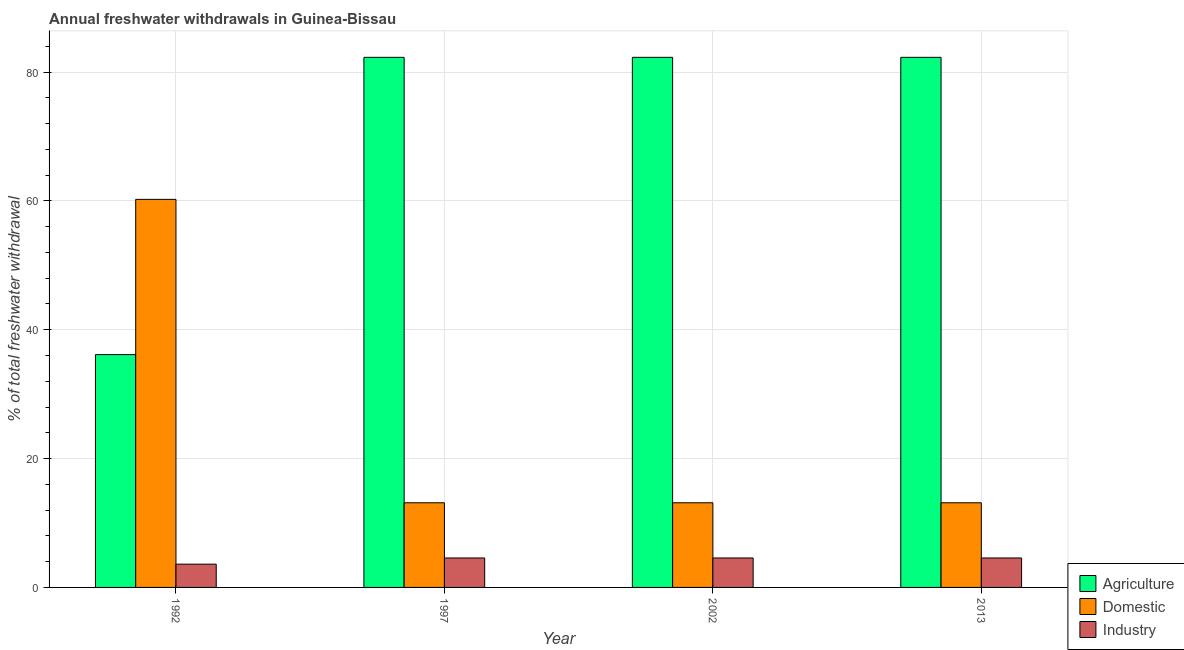How many groups of bars are there?
Your answer should be very brief. 4. How many bars are there on the 4th tick from the right?
Your answer should be compact. 3. What is the label of the 4th group of bars from the left?
Ensure brevity in your answer.  2013. What is the percentage of freshwater withdrawal for industry in 2002?
Make the answer very short. 4.57. Across all years, what is the maximum percentage of freshwater withdrawal for domestic purposes?
Make the answer very short. 60.24. Across all years, what is the minimum percentage of freshwater withdrawal for industry?
Provide a succinct answer. 3.61. What is the total percentage of freshwater withdrawal for agriculture in the graph?
Give a very brief answer. 283.01. What is the difference between the percentage of freshwater withdrawal for domestic purposes in 2002 and that in 2013?
Your answer should be very brief. 0. What is the difference between the percentage of freshwater withdrawal for agriculture in 1992 and the percentage of freshwater withdrawal for domestic purposes in 2002?
Provide a succinct answer. -46.15. What is the average percentage of freshwater withdrawal for domestic purposes per year?
Ensure brevity in your answer.  24.91. In the year 1997, what is the difference between the percentage of freshwater withdrawal for agriculture and percentage of freshwater withdrawal for domestic purposes?
Ensure brevity in your answer.  0. What is the difference between the highest and the second highest percentage of freshwater withdrawal for agriculture?
Your response must be concise. 0. What is the difference between the highest and the lowest percentage of freshwater withdrawal for industry?
Give a very brief answer. 0.96. In how many years, is the percentage of freshwater withdrawal for domestic purposes greater than the average percentage of freshwater withdrawal for domestic purposes taken over all years?
Offer a terse response. 1. Is the sum of the percentage of freshwater withdrawal for agriculture in 2002 and 2013 greater than the maximum percentage of freshwater withdrawal for domestic purposes across all years?
Your answer should be very brief. Yes. What does the 3rd bar from the left in 2013 represents?
Provide a short and direct response. Industry. What does the 1st bar from the right in 2002 represents?
Provide a short and direct response. Industry. Is it the case that in every year, the sum of the percentage of freshwater withdrawal for agriculture and percentage of freshwater withdrawal for domestic purposes is greater than the percentage of freshwater withdrawal for industry?
Provide a succinct answer. Yes. How many bars are there?
Offer a terse response. 12. What is the difference between two consecutive major ticks on the Y-axis?
Your answer should be very brief. 20. Are the values on the major ticks of Y-axis written in scientific E-notation?
Provide a succinct answer. No. Does the graph contain grids?
Your response must be concise. Yes. Where does the legend appear in the graph?
Your answer should be compact. Bottom right. How are the legend labels stacked?
Give a very brief answer. Vertical. What is the title of the graph?
Give a very brief answer. Annual freshwater withdrawals in Guinea-Bissau. Does "Renewable sources" appear as one of the legend labels in the graph?
Your answer should be very brief. No. What is the label or title of the X-axis?
Make the answer very short. Year. What is the label or title of the Y-axis?
Your answer should be compact. % of total freshwater withdrawal. What is the % of total freshwater withdrawal of Agriculture in 1992?
Your answer should be compact. 36.14. What is the % of total freshwater withdrawal of Domestic in 1992?
Your response must be concise. 60.24. What is the % of total freshwater withdrawal of Industry in 1992?
Keep it short and to the point. 3.61. What is the % of total freshwater withdrawal in Agriculture in 1997?
Ensure brevity in your answer.  82.29. What is the % of total freshwater withdrawal in Domestic in 1997?
Give a very brief answer. 13.14. What is the % of total freshwater withdrawal in Industry in 1997?
Give a very brief answer. 4.57. What is the % of total freshwater withdrawal of Agriculture in 2002?
Your answer should be compact. 82.29. What is the % of total freshwater withdrawal in Domestic in 2002?
Keep it short and to the point. 13.14. What is the % of total freshwater withdrawal of Industry in 2002?
Keep it short and to the point. 4.57. What is the % of total freshwater withdrawal of Agriculture in 2013?
Provide a short and direct response. 82.29. What is the % of total freshwater withdrawal in Domestic in 2013?
Provide a short and direct response. 13.14. What is the % of total freshwater withdrawal in Industry in 2013?
Your answer should be very brief. 4.57. Across all years, what is the maximum % of total freshwater withdrawal of Agriculture?
Give a very brief answer. 82.29. Across all years, what is the maximum % of total freshwater withdrawal in Domestic?
Your response must be concise. 60.24. Across all years, what is the maximum % of total freshwater withdrawal of Industry?
Give a very brief answer. 4.57. Across all years, what is the minimum % of total freshwater withdrawal of Agriculture?
Offer a terse response. 36.14. Across all years, what is the minimum % of total freshwater withdrawal of Domestic?
Give a very brief answer. 13.14. Across all years, what is the minimum % of total freshwater withdrawal in Industry?
Your answer should be very brief. 3.61. What is the total % of total freshwater withdrawal of Agriculture in the graph?
Keep it short and to the point. 283.01. What is the total % of total freshwater withdrawal in Domestic in the graph?
Offer a very short reply. 99.66. What is the total % of total freshwater withdrawal in Industry in the graph?
Keep it short and to the point. 17.33. What is the difference between the % of total freshwater withdrawal of Agriculture in 1992 and that in 1997?
Provide a short and direct response. -46.15. What is the difference between the % of total freshwater withdrawal of Domestic in 1992 and that in 1997?
Your answer should be compact. 47.1. What is the difference between the % of total freshwater withdrawal of Industry in 1992 and that in 1997?
Provide a short and direct response. -0.96. What is the difference between the % of total freshwater withdrawal of Agriculture in 1992 and that in 2002?
Your answer should be compact. -46.15. What is the difference between the % of total freshwater withdrawal of Domestic in 1992 and that in 2002?
Make the answer very short. 47.1. What is the difference between the % of total freshwater withdrawal in Industry in 1992 and that in 2002?
Provide a succinct answer. -0.96. What is the difference between the % of total freshwater withdrawal of Agriculture in 1992 and that in 2013?
Provide a succinct answer. -46.15. What is the difference between the % of total freshwater withdrawal in Domestic in 1992 and that in 2013?
Offer a terse response. 47.1. What is the difference between the % of total freshwater withdrawal in Industry in 1992 and that in 2013?
Your response must be concise. -0.96. What is the difference between the % of total freshwater withdrawal in Agriculture in 1997 and that in 2002?
Your answer should be compact. 0. What is the difference between the % of total freshwater withdrawal in Domestic in 1997 and that in 2013?
Provide a succinct answer. 0. What is the difference between the % of total freshwater withdrawal of Industry in 1997 and that in 2013?
Keep it short and to the point. 0. What is the difference between the % of total freshwater withdrawal in Agriculture in 2002 and that in 2013?
Make the answer very short. 0. What is the difference between the % of total freshwater withdrawal in Agriculture in 1992 and the % of total freshwater withdrawal in Domestic in 1997?
Ensure brevity in your answer.  23. What is the difference between the % of total freshwater withdrawal in Agriculture in 1992 and the % of total freshwater withdrawal in Industry in 1997?
Offer a terse response. 31.57. What is the difference between the % of total freshwater withdrawal of Domestic in 1992 and the % of total freshwater withdrawal of Industry in 1997?
Make the answer very short. 55.67. What is the difference between the % of total freshwater withdrawal in Agriculture in 1992 and the % of total freshwater withdrawal in Domestic in 2002?
Your answer should be very brief. 23. What is the difference between the % of total freshwater withdrawal of Agriculture in 1992 and the % of total freshwater withdrawal of Industry in 2002?
Offer a very short reply. 31.57. What is the difference between the % of total freshwater withdrawal in Domestic in 1992 and the % of total freshwater withdrawal in Industry in 2002?
Ensure brevity in your answer.  55.67. What is the difference between the % of total freshwater withdrawal of Agriculture in 1992 and the % of total freshwater withdrawal of Industry in 2013?
Provide a short and direct response. 31.57. What is the difference between the % of total freshwater withdrawal of Domestic in 1992 and the % of total freshwater withdrawal of Industry in 2013?
Offer a very short reply. 55.67. What is the difference between the % of total freshwater withdrawal of Agriculture in 1997 and the % of total freshwater withdrawal of Domestic in 2002?
Your response must be concise. 69.15. What is the difference between the % of total freshwater withdrawal in Agriculture in 1997 and the % of total freshwater withdrawal in Industry in 2002?
Provide a succinct answer. 77.72. What is the difference between the % of total freshwater withdrawal in Domestic in 1997 and the % of total freshwater withdrawal in Industry in 2002?
Your response must be concise. 8.57. What is the difference between the % of total freshwater withdrawal in Agriculture in 1997 and the % of total freshwater withdrawal in Domestic in 2013?
Offer a terse response. 69.15. What is the difference between the % of total freshwater withdrawal of Agriculture in 1997 and the % of total freshwater withdrawal of Industry in 2013?
Give a very brief answer. 77.72. What is the difference between the % of total freshwater withdrawal of Domestic in 1997 and the % of total freshwater withdrawal of Industry in 2013?
Your answer should be very brief. 8.57. What is the difference between the % of total freshwater withdrawal of Agriculture in 2002 and the % of total freshwater withdrawal of Domestic in 2013?
Make the answer very short. 69.15. What is the difference between the % of total freshwater withdrawal in Agriculture in 2002 and the % of total freshwater withdrawal in Industry in 2013?
Your answer should be very brief. 77.72. What is the difference between the % of total freshwater withdrawal of Domestic in 2002 and the % of total freshwater withdrawal of Industry in 2013?
Give a very brief answer. 8.57. What is the average % of total freshwater withdrawal in Agriculture per year?
Offer a terse response. 70.75. What is the average % of total freshwater withdrawal of Domestic per year?
Your response must be concise. 24.91. What is the average % of total freshwater withdrawal of Industry per year?
Provide a succinct answer. 4.33. In the year 1992, what is the difference between the % of total freshwater withdrawal of Agriculture and % of total freshwater withdrawal of Domestic?
Make the answer very short. -24.1. In the year 1992, what is the difference between the % of total freshwater withdrawal of Agriculture and % of total freshwater withdrawal of Industry?
Provide a short and direct response. 32.53. In the year 1992, what is the difference between the % of total freshwater withdrawal in Domestic and % of total freshwater withdrawal in Industry?
Keep it short and to the point. 56.63. In the year 1997, what is the difference between the % of total freshwater withdrawal in Agriculture and % of total freshwater withdrawal in Domestic?
Provide a succinct answer. 69.15. In the year 1997, what is the difference between the % of total freshwater withdrawal of Agriculture and % of total freshwater withdrawal of Industry?
Your answer should be very brief. 77.72. In the year 1997, what is the difference between the % of total freshwater withdrawal in Domestic and % of total freshwater withdrawal in Industry?
Keep it short and to the point. 8.57. In the year 2002, what is the difference between the % of total freshwater withdrawal of Agriculture and % of total freshwater withdrawal of Domestic?
Ensure brevity in your answer.  69.15. In the year 2002, what is the difference between the % of total freshwater withdrawal in Agriculture and % of total freshwater withdrawal in Industry?
Offer a terse response. 77.72. In the year 2002, what is the difference between the % of total freshwater withdrawal of Domestic and % of total freshwater withdrawal of Industry?
Make the answer very short. 8.57. In the year 2013, what is the difference between the % of total freshwater withdrawal in Agriculture and % of total freshwater withdrawal in Domestic?
Ensure brevity in your answer.  69.15. In the year 2013, what is the difference between the % of total freshwater withdrawal of Agriculture and % of total freshwater withdrawal of Industry?
Keep it short and to the point. 77.72. In the year 2013, what is the difference between the % of total freshwater withdrawal of Domestic and % of total freshwater withdrawal of Industry?
Make the answer very short. 8.57. What is the ratio of the % of total freshwater withdrawal in Agriculture in 1992 to that in 1997?
Offer a terse response. 0.44. What is the ratio of the % of total freshwater withdrawal in Domestic in 1992 to that in 1997?
Give a very brief answer. 4.58. What is the ratio of the % of total freshwater withdrawal in Industry in 1992 to that in 1997?
Provide a short and direct response. 0.79. What is the ratio of the % of total freshwater withdrawal in Agriculture in 1992 to that in 2002?
Make the answer very short. 0.44. What is the ratio of the % of total freshwater withdrawal of Domestic in 1992 to that in 2002?
Your answer should be compact. 4.58. What is the ratio of the % of total freshwater withdrawal in Industry in 1992 to that in 2002?
Give a very brief answer. 0.79. What is the ratio of the % of total freshwater withdrawal in Agriculture in 1992 to that in 2013?
Provide a succinct answer. 0.44. What is the ratio of the % of total freshwater withdrawal in Domestic in 1992 to that in 2013?
Offer a terse response. 4.58. What is the ratio of the % of total freshwater withdrawal in Industry in 1992 to that in 2013?
Ensure brevity in your answer.  0.79. What is the ratio of the % of total freshwater withdrawal in Industry in 1997 to that in 2002?
Keep it short and to the point. 1. What is the ratio of the % of total freshwater withdrawal of Industry in 1997 to that in 2013?
Make the answer very short. 1. What is the ratio of the % of total freshwater withdrawal in Agriculture in 2002 to that in 2013?
Offer a terse response. 1. What is the ratio of the % of total freshwater withdrawal of Domestic in 2002 to that in 2013?
Your answer should be compact. 1. What is the ratio of the % of total freshwater withdrawal in Industry in 2002 to that in 2013?
Offer a terse response. 1. What is the difference between the highest and the second highest % of total freshwater withdrawal in Domestic?
Ensure brevity in your answer.  47.1. What is the difference between the highest and the second highest % of total freshwater withdrawal in Industry?
Ensure brevity in your answer.  0. What is the difference between the highest and the lowest % of total freshwater withdrawal of Agriculture?
Ensure brevity in your answer.  46.15. What is the difference between the highest and the lowest % of total freshwater withdrawal of Domestic?
Your answer should be very brief. 47.1. What is the difference between the highest and the lowest % of total freshwater withdrawal of Industry?
Make the answer very short. 0.96. 